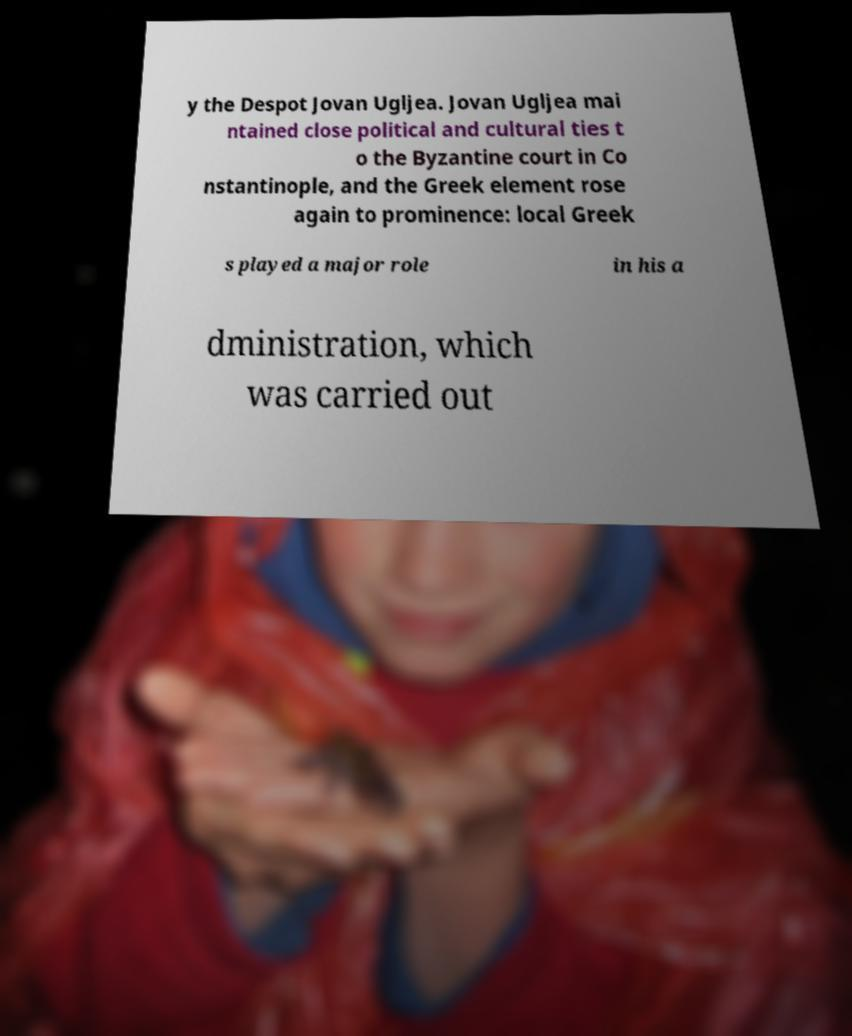There's text embedded in this image that I need extracted. Can you transcribe it verbatim? y the Despot Jovan Ugljea. Jovan Ugljea mai ntained close political and cultural ties t o the Byzantine court in Co nstantinople, and the Greek element rose again to prominence: local Greek s played a major role in his a dministration, which was carried out 